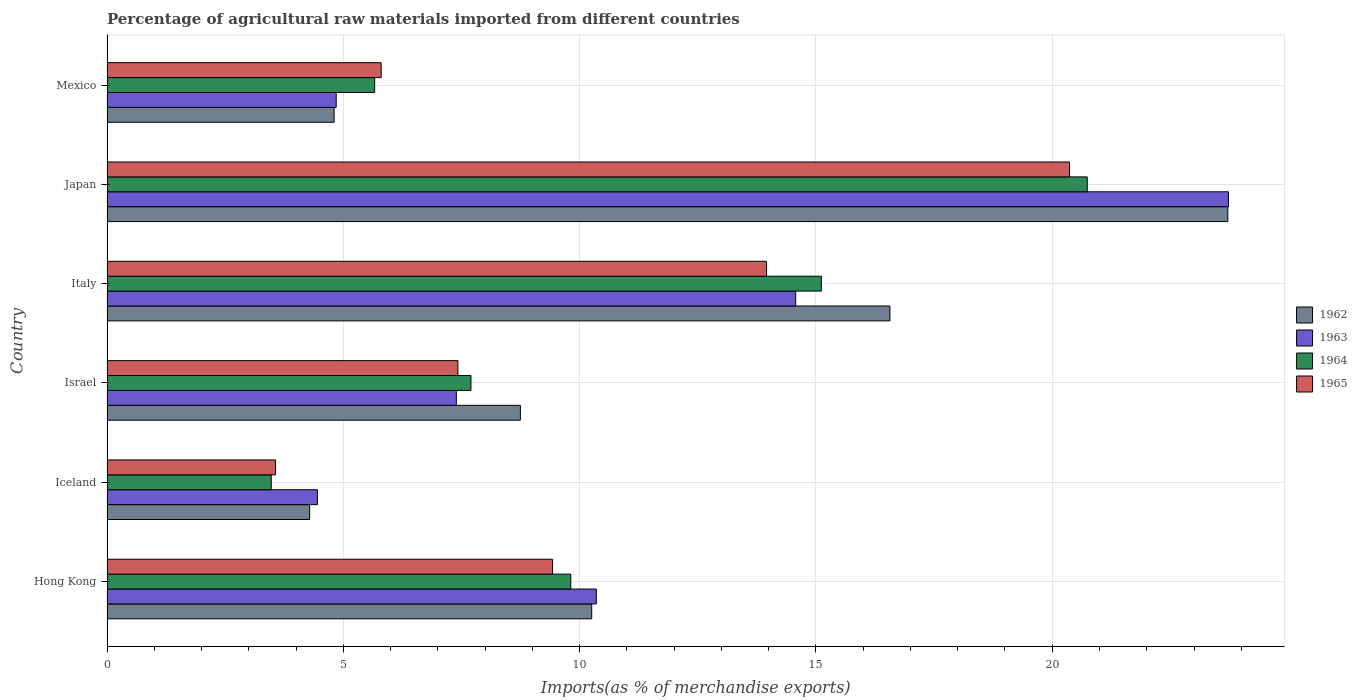How many different coloured bars are there?
Provide a succinct answer. 4. How many bars are there on the 3rd tick from the top?
Your response must be concise. 4. How many bars are there on the 1st tick from the bottom?
Your response must be concise. 4. What is the label of the 5th group of bars from the top?
Offer a very short reply. Iceland. In how many cases, is the number of bars for a given country not equal to the number of legend labels?
Offer a very short reply. 0. What is the percentage of imports to different countries in 1965 in Italy?
Provide a succinct answer. 13.95. Across all countries, what is the maximum percentage of imports to different countries in 1962?
Your answer should be very brief. 23.71. Across all countries, what is the minimum percentage of imports to different countries in 1963?
Your answer should be very brief. 4.45. What is the total percentage of imports to different countries in 1964 in the graph?
Keep it short and to the point. 62.51. What is the difference between the percentage of imports to different countries in 1965 in Iceland and that in Italy?
Offer a terse response. -10.39. What is the difference between the percentage of imports to different countries in 1963 in Japan and the percentage of imports to different countries in 1965 in Iceland?
Your answer should be very brief. 20.16. What is the average percentage of imports to different countries in 1965 per country?
Your response must be concise. 10.09. What is the difference between the percentage of imports to different countries in 1965 and percentage of imports to different countries in 1963 in Mexico?
Offer a very short reply. 0.95. In how many countries, is the percentage of imports to different countries in 1963 greater than 4 %?
Make the answer very short. 6. What is the ratio of the percentage of imports to different countries in 1963 in Hong Kong to that in Italy?
Offer a terse response. 0.71. Is the percentage of imports to different countries in 1962 in Italy less than that in Japan?
Provide a succinct answer. Yes. Is the difference between the percentage of imports to different countries in 1965 in Iceland and Japan greater than the difference between the percentage of imports to different countries in 1963 in Iceland and Japan?
Ensure brevity in your answer.  Yes. What is the difference between the highest and the second highest percentage of imports to different countries in 1964?
Provide a short and direct response. 5.63. What is the difference between the highest and the lowest percentage of imports to different countries in 1965?
Give a very brief answer. 16.8. In how many countries, is the percentage of imports to different countries in 1965 greater than the average percentage of imports to different countries in 1965 taken over all countries?
Your answer should be compact. 2. What does the 1st bar from the top in Japan represents?
Your response must be concise. 1965. What does the 3rd bar from the bottom in Japan represents?
Keep it short and to the point. 1964. Is it the case that in every country, the sum of the percentage of imports to different countries in 1962 and percentage of imports to different countries in 1963 is greater than the percentage of imports to different countries in 1965?
Provide a succinct answer. Yes. Does the graph contain any zero values?
Ensure brevity in your answer.  No. Does the graph contain grids?
Your response must be concise. Yes. Where does the legend appear in the graph?
Offer a very short reply. Center right. How many legend labels are there?
Your answer should be compact. 4. What is the title of the graph?
Give a very brief answer. Percentage of agricultural raw materials imported from different countries. What is the label or title of the X-axis?
Your response must be concise. Imports(as % of merchandise exports). What is the label or title of the Y-axis?
Ensure brevity in your answer.  Country. What is the Imports(as % of merchandise exports) in 1962 in Hong Kong?
Provide a succinct answer. 10.26. What is the Imports(as % of merchandise exports) in 1963 in Hong Kong?
Your response must be concise. 10.35. What is the Imports(as % of merchandise exports) of 1964 in Hong Kong?
Keep it short and to the point. 9.81. What is the Imports(as % of merchandise exports) of 1965 in Hong Kong?
Make the answer very short. 9.43. What is the Imports(as % of merchandise exports) of 1962 in Iceland?
Your response must be concise. 4.29. What is the Imports(as % of merchandise exports) in 1963 in Iceland?
Provide a short and direct response. 4.45. What is the Imports(as % of merchandise exports) in 1964 in Iceland?
Offer a very short reply. 3.48. What is the Imports(as % of merchandise exports) of 1965 in Iceland?
Your answer should be compact. 3.57. What is the Imports(as % of merchandise exports) in 1962 in Israel?
Your answer should be compact. 8.75. What is the Imports(as % of merchandise exports) in 1963 in Israel?
Offer a very short reply. 7.39. What is the Imports(as % of merchandise exports) in 1964 in Israel?
Give a very brief answer. 7.7. What is the Imports(as % of merchandise exports) in 1965 in Israel?
Your answer should be compact. 7.42. What is the Imports(as % of merchandise exports) in 1962 in Italy?
Offer a very short reply. 16.57. What is the Imports(as % of merchandise exports) in 1963 in Italy?
Make the answer very short. 14.57. What is the Imports(as % of merchandise exports) of 1964 in Italy?
Provide a succinct answer. 15.12. What is the Imports(as % of merchandise exports) of 1965 in Italy?
Ensure brevity in your answer.  13.95. What is the Imports(as % of merchandise exports) in 1962 in Japan?
Make the answer very short. 23.71. What is the Imports(as % of merchandise exports) in 1963 in Japan?
Your answer should be compact. 23.73. What is the Imports(as % of merchandise exports) of 1964 in Japan?
Your response must be concise. 20.74. What is the Imports(as % of merchandise exports) in 1965 in Japan?
Keep it short and to the point. 20.37. What is the Imports(as % of merchandise exports) of 1962 in Mexico?
Make the answer very short. 4.81. What is the Imports(as % of merchandise exports) in 1963 in Mexico?
Make the answer very short. 4.85. What is the Imports(as % of merchandise exports) in 1964 in Mexico?
Offer a terse response. 5.66. What is the Imports(as % of merchandise exports) in 1965 in Mexico?
Offer a terse response. 5.8. Across all countries, what is the maximum Imports(as % of merchandise exports) in 1962?
Make the answer very short. 23.71. Across all countries, what is the maximum Imports(as % of merchandise exports) in 1963?
Make the answer very short. 23.73. Across all countries, what is the maximum Imports(as % of merchandise exports) of 1964?
Offer a terse response. 20.74. Across all countries, what is the maximum Imports(as % of merchandise exports) of 1965?
Offer a terse response. 20.37. Across all countries, what is the minimum Imports(as % of merchandise exports) in 1962?
Your response must be concise. 4.29. Across all countries, what is the minimum Imports(as % of merchandise exports) in 1963?
Your answer should be very brief. 4.45. Across all countries, what is the minimum Imports(as % of merchandise exports) in 1964?
Offer a terse response. 3.48. Across all countries, what is the minimum Imports(as % of merchandise exports) in 1965?
Your answer should be compact. 3.57. What is the total Imports(as % of merchandise exports) of 1962 in the graph?
Ensure brevity in your answer.  68.38. What is the total Imports(as % of merchandise exports) of 1963 in the graph?
Give a very brief answer. 65.35. What is the total Imports(as % of merchandise exports) in 1964 in the graph?
Provide a short and direct response. 62.51. What is the total Imports(as % of merchandise exports) in 1965 in the graph?
Your answer should be compact. 60.54. What is the difference between the Imports(as % of merchandise exports) of 1962 in Hong Kong and that in Iceland?
Make the answer very short. 5.97. What is the difference between the Imports(as % of merchandise exports) of 1963 in Hong Kong and that in Iceland?
Your answer should be very brief. 5.9. What is the difference between the Imports(as % of merchandise exports) of 1964 in Hong Kong and that in Iceland?
Ensure brevity in your answer.  6.34. What is the difference between the Imports(as % of merchandise exports) in 1965 in Hong Kong and that in Iceland?
Offer a very short reply. 5.86. What is the difference between the Imports(as % of merchandise exports) in 1962 in Hong Kong and that in Israel?
Offer a very short reply. 1.51. What is the difference between the Imports(as % of merchandise exports) of 1963 in Hong Kong and that in Israel?
Give a very brief answer. 2.96. What is the difference between the Imports(as % of merchandise exports) in 1964 in Hong Kong and that in Israel?
Offer a terse response. 2.11. What is the difference between the Imports(as % of merchandise exports) of 1965 in Hong Kong and that in Israel?
Ensure brevity in your answer.  2. What is the difference between the Imports(as % of merchandise exports) in 1962 in Hong Kong and that in Italy?
Keep it short and to the point. -6.31. What is the difference between the Imports(as % of merchandise exports) in 1963 in Hong Kong and that in Italy?
Keep it short and to the point. -4.22. What is the difference between the Imports(as % of merchandise exports) of 1964 in Hong Kong and that in Italy?
Keep it short and to the point. -5.3. What is the difference between the Imports(as % of merchandise exports) of 1965 in Hong Kong and that in Italy?
Your answer should be very brief. -4.53. What is the difference between the Imports(as % of merchandise exports) of 1962 in Hong Kong and that in Japan?
Offer a terse response. -13.46. What is the difference between the Imports(as % of merchandise exports) of 1963 in Hong Kong and that in Japan?
Provide a succinct answer. -13.38. What is the difference between the Imports(as % of merchandise exports) in 1964 in Hong Kong and that in Japan?
Your response must be concise. -10.93. What is the difference between the Imports(as % of merchandise exports) of 1965 in Hong Kong and that in Japan?
Your answer should be very brief. -10.94. What is the difference between the Imports(as % of merchandise exports) of 1962 in Hong Kong and that in Mexico?
Make the answer very short. 5.45. What is the difference between the Imports(as % of merchandise exports) of 1963 in Hong Kong and that in Mexico?
Your answer should be very brief. 5.5. What is the difference between the Imports(as % of merchandise exports) in 1964 in Hong Kong and that in Mexico?
Make the answer very short. 4.15. What is the difference between the Imports(as % of merchandise exports) of 1965 in Hong Kong and that in Mexico?
Make the answer very short. 3.63. What is the difference between the Imports(as % of merchandise exports) of 1962 in Iceland and that in Israel?
Give a very brief answer. -4.46. What is the difference between the Imports(as % of merchandise exports) of 1963 in Iceland and that in Israel?
Offer a terse response. -2.94. What is the difference between the Imports(as % of merchandise exports) in 1964 in Iceland and that in Israel?
Your response must be concise. -4.23. What is the difference between the Imports(as % of merchandise exports) in 1965 in Iceland and that in Israel?
Keep it short and to the point. -3.86. What is the difference between the Imports(as % of merchandise exports) in 1962 in Iceland and that in Italy?
Ensure brevity in your answer.  -12.28. What is the difference between the Imports(as % of merchandise exports) of 1963 in Iceland and that in Italy?
Ensure brevity in your answer.  -10.12. What is the difference between the Imports(as % of merchandise exports) in 1964 in Iceland and that in Italy?
Keep it short and to the point. -11.64. What is the difference between the Imports(as % of merchandise exports) in 1965 in Iceland and that in Italy?
Your answer should be compact. -10.39. What is the difference between the Imports(as % of merchandise exports) in 1962 in Iceland and that in Japan?
Provide a succinct answer. -19.43. What is the difference between the Imports(as % of merchandise exports) in 1963 in Iceland and that in Japan?
Your answer should be compact. -19.28. What is the difference between the Imports(as % of merchandise exports) in 1964 in Iceland and that in Japan?
Offer a very short reply. -17.27. What is the difference between the Imports(as % of merchandise exports) of 1965 in Iceland and that in Japan?
Make the answer very short. -16.8. What is the difference between the Imports(as % of merchandise exports) of 1962 in Iceland and that in Mexico?
Provide a short and direct response. -0.52. What is the difference between the Imports(as % of merchandise exports) in 1963 in Iceland and that in Mexico?
Give a very brief answer. -0.4. What is the difference between the Imports(as % of merchandise exports) of 1964 in Iceland and that in Mexico?
Your response must be concise. -2.19. What is the difference between the Imports(as % of merchandise exports) in 1965 in Iceland and that in Mexico?
Make the answer very short. -2.23. What is the difference between the Imports(as % of merchandise exports) in 1962 in Israel and that in Italy?
Offer a terse response. -7.82. What is the difference between the Imports(as % of merchandise exports) in 1963 in Israel and that in Italy?
Your answer should be compact. -7.18. What is the difference between the Imports(as % of merchandise exports) in 1964 in Israel and that in Italy?
Your answer should be compact. -7.41. What is the difference between the Imports(as % of merchandise exports) in 1965 in Israel and that in Italy?
Offer a very short reply. -6.53. What is the difference between the Imports(as % of merchandise exports) in 1962 in Israel and that in Japan?
Provide a short and direct response. -14.97. What is the difference between the Imports(as % of merchandise exports) of 1963 in Israel and that in Japan?
Your answer should be very brief. -16.34. What is the difference between the Imports(as % of merchandise exports) of 1964 in Israel and that in Japan?
Make the answer very short. -13.04. What is the difference between the Imports(as % of merchandise exports) of 1965 in Israel and that in Japan?
Your answer should be very brief. -12.94. What is the difference between the Imports(as % of merchandise exports) of 1962 in Israel and that in Mexico?
Offer a terse response. 3.94. What is the difference between the Imports(as % of merchandise exports) in 1963 in Israel and that in Mexico?
Give a very brief answer. 2.54. What is the difference between the Imports(as % of merchandise exports) in 1964 in Israel and that in Mexico?
Your answer should be very brief. 2.04. What is the difference between the Imports(as % of merchandise exports) in 1965 in Israel and that in Mexico?
Your answer should be very brief. 1.62. What is the difference between the Imports(as % of merchandise exports) of 1962 in Italy and that in Japan?
Keep it short and to the point. -7.15. What is the difference between the Imports(as % of merchandise exports) in 1963 in Italy and that in Japan?
Give a very brief answer. -9.16. What is the difference between the Imports(as % of merchandise exports) of 1964 in Italy and that in Japan?
Offer a terse response. -5.63. What is the difference between the Imports(as % of merchandise exports) of 1965 in Italy and that in Japan?
Offer a terse response. -6.41. What is the difference between the Imports(as % of merchandise exports) in 1962 in Italy and that in Mexico?
Offer a very short reply. 11.76. What is the difference between the Imports(as % of merchandise exports) in 1963 in Italy and that in Mexico?
Your response must be concise. 9.72. What is the difference between the Imports(as % of merchandise exports) of 1964 in Italy and that in Mexico?
Your answer should be compact. 9.45. What is the difference between the Imports(as % of merchandise exports) in 1965 in Italy and that in Mexico?
Provide a succinct answer. 8.15. What is the difference between the Imports(as % of merchandise exports) of 1962 in Japan and that in Mexico?
Keep it short and to the point. 18.91. What is the difference between the Imports(as % of merchandise exports) in 1963 in Japan and that in Mexico?
Your response must be concise. 18.88. What is the difference between the Imports(as % of merchandise exports) of 1964 in Japan and that in Mexico?
Keep it short and to the point. 15.08. What is the difference between the Imports(as % of merchandise exports) of 1965 in Japan and that in Mexico?
Your response must be concise. 14.56. What is the difference between the Imports(as % of merchandise exports) of 1962 in Hong Kong and the Imports(as % of merchandise exports) of 1963 in Iceland?
Your response must be concise. 5.8. What is the difference between the Imports(as % of merchandise exports) in 1962 in Hong Kong and the Imports(as % of merchandise exports) in 1964 in Iceland?
Your response must be concise. 6.78. What is the difference between the Imports(as % of merchandise exports) in 1962 in Hong Kong and the Imports(as % of merchandise exports) in 1965 in Iceland?
Ensure brevity in your answer.  6.69. What is the difference between the Imports(as % of merchandise exports) of 1963 in Hong Kong and the Imports(as % of merchandise exports) of 1964 in Iceland?
Offer a terse response. 6.88. What is the difference between the Imports(as % of merchandise exports) of 1963 in Hong Kong and the Imports(as % of merchandise exports) of 1965 in Iceland?
Make the answer very short. 6.79. What is the difference between the Imports(as % of merchandise exports) in 1964 in Hong Kong and the Imports(as % of merchandise exports) in 1965 in Iceland?
Make the answer very short. 6.25. What is the difference between the Imports(as % of merchandise exports) of 1962 in Hong Kong and the Imports(as % of merchandise exports) of 1963 in Israel?
Make the answer very short. 2.86. What is the difference between the Imports(as % of merchandise exports) of 1962 in Hong Kong and the Imports(as % of merchandise exports) of 1964 in Israel?
Your answer should be very brief. 2.55. What is the difference between the Imports(as % of merchandise exports) in 1962 in Hong Kong and the Imports(as % of merchandise exports) in 1965 in Israel?
Your answer should be very brief. 2.83. What is the difference between the Imports(as % of merchandise exports) in 1963 in Hong Kong and the Imports(as % of merchandise exports) in 1964 in Israel?
Give a very brief answer. 2.65. What is the difference between the Imports(as % of merchandise exports) of 1963 in Hong Kong and the Imports(as % of merchandise exports) of 1965 in Israel?
Make the answer very short. 2.93. What is the difference between the Imports(as % of merchandise exports) of 1964 in Hong Kong and the Imports(as % of merchandise exports) of 1965 in Israel?
Your response must be concise. 2.39. What is the difference between the Imports(as % of merchandise exports) in 1962 in Hong Kong and the Imports(as % of merchandise exports) in 1963 in Italy?
Give a very brief answer. -4.32. What is the difference between the Imports(as % of merchandise exports) in 1962 in Hong Kong and the Imports(as % of merchandise exports) in 1964 in Italy?
Your response must be concise. -4.86. What is the difference between the Imports(as % of merchandise exports) of 1962 in Hong Kong and the Imports(as % of merchandise exports) of 1965 in Italy?
Offer a terse response. -3.7. What is the difference between the Imports(as % of merchandise exports) in 1963 in Hong Kong and the Imports(as % of merchandise exports) in 1964 in Italy?
Provide a succinct answer. -4.76. What is the difference between the Imports(as % of merchandise exports) in 1963 in Hong Kong and the Imports(as % of merchandise exports) in 1965 in Italy?
Provide a succinct answer. -3.6. What is the difference between the Imports(as % of merchandise exports) in 1964 in Hong Kong and the Imports(as % of merchandise exports) in 1965 in Italy?
Your response must be concise. -4.14. What is the difference between the Imports(as % of merchandise exports) of 1962 in Hong Kong and the Imports(as % of merchandise exports) of 1963 in Japan?
Ensure brevity in your answer.  -13.47. What is the difference between the Imports(as % of merchandise exports) of 1962 in Hong Kong and the Imports(as % of merchandise exports) of 1964 in Japan?
Your answer should be compact. -10.49. What is the difference between the Imports(as % of merchandise exports) of 1962 in Hong Kong and the Imports(as % of merchandise exports) of 1965 in Japan?
Offer a terse response. -10.11. What is the difference between the Imports(as % of merchandise exports) of 1963 in Hong Kong and the Imports(as % of merchandise exports) of 1964 in Japan?
Offer a terse response. -10.39. What is the difference between the Imports(as % of merchandise exports) in 1963 in Hong Kong and the Imports(as % of merchandise exports) in 1965 in Japan?
Offer a terse response. -10.01. What is the difference between the Imports(as % of merchandise exports) of 1964 in Hong Kong and the Imports(as % of merchandise exports) of 1965 in Japan?
Provide a short and direct response. -10.55. What is the difference between the Imports(as % of merchandise exports) of 1962 in Hong Kong and the Imports(as % of merchandise exports) of 1963 in Mexico?
Offer a very short reply. 5.41. What is the difference between the Imports(as % of merchandise exports) in 1962 in Hong Kong and the Imports(as % of merchandise exports) in 1964 in Mexico?
Provide a short and direct response. 4.59. What is the difference between the Imports(as % of merchandise exports) in 1962 in Hong Kong and the Imports(as % of merchandise exports) in 1965 in Mexico?
Ensure brevity in your answer.  4.45. What is the difference between the Imports(as % of merchandise exports) in 1963 in Hong Kong and the Imports(as % of merchandise exports) in 1964 in Mexico?
Your answer should be compact. 4.69. What is the difference between the Imports(as % of merchandise exports) in 1963 in Hong Kong and the Imports(as % of merchandise exports) in 1965 in Mexico?
Offer a terse response. 4.55. What is the difference between the Imports(as % of merchandise exports) in 1964 in Hong Kong and the Imports(as % of merchandise exports) in 1965 in Mexico?
Offer a terse response. 4.01. What is the difference between the Imports(as % of merchandise exports) in 1962 in Iceland and the Imports(as % of merchandise exports) in 1963 in Israel?
Make the answer very short. -3.1. What is the difference between the Imports(as % of merchandise exports) in 1962 in Iceland and the Imports(as % of merchandise exports) in 1964 in Israel?
Give a very brief answer. -3.41. What is the difference between the Imports(as % of merchandise exports) of 1962 in Iceland and the Imports(as % of merchandise exports) of 1965 in Israel?
Keep it short and to the point. -3.14. What is the difference between the Imports(as % of merchandise exports) of 1963 in Iceland and the Imports(as % of merchandise exports) of 1964 in Israel?
Ensure brevity in your answer.  -3.25. What is the difference between the Imports(as % of merchandise exports) in 1963 in Iceland and the Imports(as % of merchandise exports) in 1965 in Israel?
Your answer should be very brief. -2.97. What is the difference between the Imports(as % of merchandise exports) in 1964 in Iceland and the Imports(as % of merchandise exports) in 1965 in Israel?
Offer a very short reply. -3.95. What is the difference between the Imports(as % of merchandise exports) of 1962 in Iceland and the Imports(as % of merchandise exports) of 1963 in Italy?
Ensure brevity in your answer.  -10.28. What is the difference between the Imports(as % of merchandise exports) of 1962 in Iceland and the Imports(as % of merchandise exports) of 1964 in Italy?
Keep it short and to the point. -10.83. What is the difference between the Imports(as % of merchandise exports) in 1962 in Iceland and the Imports(as % of merchandise exports) in 1965 in Italy?
Give a very brief answer. -9.67. What is the difference between the Imports(as % of merchandise exports) in 1963 in Iceland and the Imports(as % of merchandise exports) in 1964 in Italy?
Offer a very short reply. -10.66. What is the difference between the Imports(as % of merchandise exports) in 1963 in Iceland and the Imports(as % of merchandise exports) in 1965 in Italy?
Your answer should be compact. -9.5. What is the difference between the Imports(as % of merchandise exports) of 1964 in Iceland and the Imports(as % of merchandise exports) of 1965 in Italy?
Your answer should be compact. -10.48. What is the difference between the Imports(as % of merchandise exports) in 1962 in Iceland and the Imports(as % of merchandise exports) in 1963 in Japan?
Provide a succinct answer. -19.44. What is the difference between the Imports(as % of merchandise exports) in 1962 in Iceland and the Imports(as % of merchandise exports) in 1964 in Japan?
Make the answer very short. -16.45. What is the difference between the Imports(as % of merchandise exports) of 1962 in Iceland and the Imports(as % of merchandise exports) of 1965 in Japan?
Offer a very short reply. -16.08. What is the difference between the Imports(as % of merchandise exports) in 1963 in Iceland and the Imports(as % of merchandise exports) in 1964 in Japan?
Ensure brevity in your answer.  -16.29. What is the difference between the Imports(as % of merchandise exports) in 1963 in Iceland and the Imports(as % of merchandise exports) in 1965 in Japan?
Provide a succinct answer. -15.91. What is the difference between the Imports(as % of merchandise exports) of 1964 in Iceland and the Imports(as % of merchandise exports) of 1965 in Japan?
Provide a short and direct response. -16.89. What is the difference between the Imports(as % of merchandise exports) of 1962 in Iceland and the Imports(as % of merchandise exports) of 1963 in Mexico?
Give a very brief answer. -0.56. What is the difference between the Imports(as % of merchandise exports) of 1962 in Iceland and the Imports(as % of merchandise exports) of 1964 in Mexico?
Ensure brevity in your answer.  -1.38. What is the difference between the Imports(as % of merchandise exports) in 1962 in Iceland and the Imports(as % of merchandise exports) in 1965 in Mexico?
Your answer should be very brief. -1.51. What is the difference between the Imports(as % of merchandise exports) of 1963 in Iceland and the Imports(as % of merchandise exports) of 1964 in Mexico?
Keep it short and to the point. -1.21. What is the difference between the Imports(as % of merchandise exports) of 1963 in Iceland and the Imports(as % of merchandise exports) of 1965 in Mexico?
Ensure brevity in your answer.  -1.35. What is the difference between the Imports(as % of merchandise exports) in 1964 in Iceland and the Imports(as % of merchandise exports) in 1965 in Mexico?
Keep it short and to the point. -2.33. What is the difference between the Imports(as % of merchandise exports) in 1962 in Israel and the Imports(as % of merchandise exports) in 1963 in Italy?
Ensure brevity in your answer.  -5.83. What is the difference between the Imports(as % of merchandise exports) in 1962 in Israel and the Imports(as % of merchandise exports) in 1964 in Italy?
Offer a very short reply. -6.37. What is the difference between the Imports(as % of merchandise exports) of 1962 in Israel and the Imports(as % of merchandise exports) of 1965 in Italy?
Your answer should be very brief. -5.21. What is the difference between the Imports(as % of merchandise exports) in 1963 in Israel and the Imports(as % of merchandise exports) in 1964 in Italy?
Offer a very short reply. -7.72. What is the difference between the Imports(as % of merchandise exports) in 1963 in Israel and the Imports(as % of merchandise exports) in 1965 in Italy?
Make the answer very short. -6.56. What is the difference between the Imports(as % of merchandise exports) of 1964 in Israel and the Imports(as % of merchandise exports) of 1965 in Italy?
Your response must be concise. -6.25. What is the difference between the Imports(as % of merchandise exports) in 1962 in Israel and the Imports(as % of merchandise exports) in 1963 in Japan?
Your answer should be compact. -14.98. What is the difference between the Imports(as % of merchandise exports) of 1962 in Israel and the Imports(as % of merchandise exports) of 1964 in Japan?
Your answer should be compact. -11.99. What is the difference between the Imports(as % of merchandise exports) in 1962 in Israel and the Imports(as % of merchandise exports) in 1965 in Japan?
Your answer should be compact. -11.62. What is the difference between the Imports(as % of merchandise exports) in 1963 in Israel and the Imports(as % of merchandise exports) in 1964 in Japan?
Keep it short and to the point. -13.35. What is the difference between the Imports(as % of merchandise exports) in 1963 in Israel and the Imports(as % of merchandise exports) in 1965 in Japan?
Ensure brevity in your answer.  -12.97. What is the difference between the Imports(as % of merchandise exports) in 1964 in Israel and the Imports(as % of merchandise exports) in 1965 in Japan?
Offer a very short reply. -12.67. What is the difference between the Imports(as % of merchandise exports) of 1962 in Israel and the Imports(as % of merchandise exports) of 1963 in Mexico?
Your response must be concise. 3.9. What is the difference between the Imports(as % of merchandise exports) in 1962 in Israel and the Imports(as % of merchandise exports) in 1964 in Mexico?
Your answer should be very brief. 3.08. What is the difference between the Imports(as % of merchandise exports) in 1962 in Israel and the Imports(as % of merchandise exports) in 1965 in Mexico?
Provide a short and direct response. 2.95. What is the difference between the Imports(as % of merchandise exports) of 1963 in Israel and the Imports(as % of merchandise exports) of 1964 in Mexico?
Your response must be concise. 1.73. What is the difference between the Imports(as % of merchandise exports) of 1963 in Israel and the Imports(as % of merchandise exports) of 1965 in Mexico?
Provide a short and direct response. 1.59. What is the difference between the Imports(as % of merchandise exports) of 1964 in Israel and the Imports(as % of merchandise exports) of 1965 in Mexico?
Keep it short and to the point. 1.9. What is the difference between the Imports(as % of merchandise exports) in 1962 in Italy and the Imports(as % of merchandise exports) in 1963 in Japan?
Your response must be concise. -7.16. What is the difference between the Imports(as % of merchandise exports) in 1962 in Italy and the Imports(as % of merchandise exports) in 1964 in Japan?
Offer a very short reply. -4.18. What is the difference between the Imports(as % of merchandise exports) of 1962 in Italy and the Imports(as % of merchandise exports) of 1965 in Japan?
Offer a terse response. -3.8. What is the difference between the Imports(as % of merchandise exports) of 1963 in Italy and the Imports(as % of merchandise exports) of 1964 in Japan?
Provide a succinct answer. -6.17. What is the difference between the Imports(as % of merchandise exports) of 1963 in Italy and the Imports(as % of merchandise exports) of 1965 in Japan?
Offer a very short reply. -5.79. What is the difference between the Imports(as % of merchandise exports) in 1964 in Italy and the Imports(as % of merchandise exports) in 1965 in Japan?
Your answer should be compact. -5.25. What is the difference between the Imports(as % of merchandise exports) of 1962 in Italy and the Imports(as % of merchandise exports) of 1963 in Mexico?
Offer a terse response. 11.72. What is the difference between the Imports(as % of merchandise exports) in 1962 in Italy and the Imports(as % of merchandise exports) in 1964 in Mexico?
Your answer should be very brief. 10.9. What is the difference between the Imports(as % of merchandise exports) of 1962 in Italy and the Imports(as % of merchandise exports) of 1965 in Mexico?
Your answer should be very brief. 10.76. What is the difference between the Imports(as % of merchandise exports) of 1963 in Italy and the Imports(as % of merchandise exports) of 1964 in Mexico?
Make the answer very short. 8.91. What is the difference between the Imports(as % of merchandise exports) in 1963 in Italy and the Imports(as % of merchandise exports) in 1965 in Mexico?
Your answer should be very brief. 8.77. What is the difference between the Imports(as % of merchandise exports) in 1964 in Italy and the Imports(as % of merchandise exports) in 1965 in Mexico?
Give a very brief answer. 9.31. What is the difference between the Imports(as % of merchandise exports) of 1962 in Japan and the Imports(as % of merchandise exports) of 1963 in Mexico?
Your answer should be very brief. 18.87. What is the difference between the Imports(as % of merchandise exports) in 1962 in Japan and the Imports(as % of merchandise exports) in 1964 in Mexico?
Offer a terse response. 18.05. What is the difference between the Imports(as % of merchandise exports) in 1962 in Japan and the Imports(as % of merchandise exports) in 1965 in Mexico?
Your response must be concise. 17.91. What is the difference between the Imports(as % of merchandise exports) of 1963 in Japan and the Imports(as % of merchandise exports) of 1964 in Mexico?
Keep it short and to the point. 18.07. What is the difference between the Imports(as % of merchandise exports) in 1963 in Japan and the Imports(as % of merchandise exports) in 1965 in Mexico?
Offer a terse response. 17.93. What is the difference between the Imports(as % of merchandise exports) in 1964 in Japan and the Imports(as % of merchandise exports) in 1965 in Mexico?
Your answer should be compact. 14.94. What is the average Imports(as % of merchandise exports) in 1962 per country?
Your response must be concise. 11.4. What is the average Imports(as % of merchandise exports) in 1963 per country?
Offer a very short reply. 10.89. What is the average Imports(as % of merchandise exports) of 1964 per country?
Your answer should be very brief. 10.42. What is the average Imports(as % of merchandise exports) of 1965 per country?
Your response must be concise. 10.09. What is the difference between the Imports(as % of merchandise exports) in 1962 and Imports(as % of merchandise exports) in 1963 in Hong Kong?
Provide a succinct answer. -0.1. What is the difference between the Imports(as % of merchandise exports) in 1962 and Imports(as % of merchandise exports) in 1964 in Hong Kong?
Give a very brief answer. 0.44. What is the difference between the Imports(as % of merchandise exports) in 1962 and Imports(as % of merchandise exports) in 1965 in Hong Kong?
Give a very brief answer. 0.83. What is the difference between the Imports(as % of merchandise exports) in 1963 and Imports(as % of merchandise exports) in 1964 in Hong Kong?
Your response must be concise. 0.54. What is the difference between the Imports(as % of merchandise exports) in 1963 and Imports(as % of merchandise exports) in 1965 in Hong Kong?
Make the answer very short. 0.93. What is the difference between the Imports(as % of merchandise exports) of 1964 and Imports(as % of merchandise exports) of 1965 in Hong Kong?
Offer a terse response. 0.39. What is the difference between the Imports(as % of merchandise exports) in 1962 and Imports(as % of merchandise exports) in 1963 in Iceland?
Your answer should be very brief. -0.16. What is the difference between the Imports(as % of merchandise exports) of 1962 and Imports(as % of merchandise exports) of 1964 in Iceland?
Your answer should be very brief. 0.81. What is the difference between the Imports(as % of merchandise exports) in 1962 and Imports(as % of merchandise exports) in 1965 in Iceland?
Keep it short and to the point. 0.72. What is the difference between the Imports(as % of merchandise exports) of 1963 and Imports(as % of merchandise exports) of 1964 in Iceland?
Provide a succinct answer. 0.98. What is the difference between the Imports(as % of merchandise exports) of 1963 and Imports(as % of merchandise exports) of 1965 in Iceland?
Your answer should be very brief. 0.89. What is the difference between the Imports(as % of merchandise exports) of 1964 and Imports(as % of merchandise exports) of 1965 in Iceland?
Offer a very short reply. -0.09. What is the difference between the Imports(as % of merchandise exports) in 1962 and Imports(as % of merchandise exports) in 1963 in Israel?
Ensure brevity in your answer.  1.36. What is the difference between the Imports(as % of merchandise exports) in 1962 and Imports(as % of merchandise exports) in 1964 in Israel?
Provide a short and direct response. 1.05. What is the difference between the Imports(as % of merchandise exports) of 1962 and Imports(as % of merchandise exports) of 1965 in Israel?
Your response must be concise. 1.32. What is the difference between the Imports(as % of merchandise exports) of 1963 and Imports(as % of merchandise exports) of 1964 in Israel?
Your answer should be very brief. -0.31. What is the difference between the Imports(as % of merchandise exports) in 1963 and Imports(as % of merchandise exports) in 1965 in Israel?
Make the answer very short. -0.03. What is the difference between the Imports(as % of merchandise exports) in 1964 and Imports(as % of merchandise exports) in 1965 in Israel?
Offer a very short reply. 0.28. What is the difference between the Imports(as % of merchandise exports) in 1962 and Imports(as % of merchandise exports) in 1963 in Italy?
Ensure brevity in your answer.  1.99. What is the difference between the Imports(as % of merchandise exports) of 1962 and Imports(as % of merchandise exports) of 1964 in Italy?
Provide a succinct answer. 1.45. What is the difference between the Imports(as % of merchandise exports) in 1962 and Imports(as % of merchandise exports) in 1965 in Italy?
Keep it short and to the point. 2.61. What is the difference between the Imports(as % of merchandise exports) in 1963 and Imports(as % of merchandise exports) in 1964 in Italy?
Provide a short and direct response. -0.54. What is the difference between the Imports(as % of merchandise exports) in 1963 and Imports(as % of merchandise exports) in 1965 in Italy?
Keep it short and to the point. 0.62. What is the difference between the Imports(as % of merchandise exports) in 1964 and Imports(as % of merchandise exports) in 1965 in Italy?
Provide a short and direct response. 1.16. What is the difference between the Imports(as % of merchandise exports) of 1962 and Imports(as % of merchandise exports) of 1963 in Japan?
Your answer should be very brief. -0.01. What is the difference between the Imports(as % of merchandise exports) in 1962 and Imports(as % of merchandise exports) in 1964 in Japan?
Give a very brief answer. 2.97. What is the difference between the Imports(as % of merchandise exports) of 1962 and Imports(as % of merchandise exports) of 1965 in Japan?
Your answer should be compact. 3.35. What is the difference between the Imports(as % of merchandise exports) in 1963 and Imports(as % of merchandise exports) in 1964 in Japan?
Provide a succinct answer. 2.99. What is the difference between the Imports(as % of merchandise exports) in 1963 and Imports(as % of merchandise exports) in 1965 in Japan?
Make the answer very short. 3.36. What is the difference between the Imports(as % of merchandise exports) in 1964 and Imports(as % of merchandise exports) in 1965 in Japan?
Your response must be concise. 0.38. What is the difference between the Imports(as % of merchandise exports) in 1962 and Imports(as % of merchandise exports) in 1963 in Mexico?
Offer a terse response. -0.04. What is the difference between the Imports(as % of merchandise exports) in 1962 and Imports(as % of merchandise exports) in 1964 in Mexico?
Your answer should be very brief. -0.86. What is the difference between the Imports(as % of merchandise exports) in 1962 and Imports(as % of merchandise exports) in 1965 in Mexico?
Provide a short and direct response. -1. What is the difference between the Imports(as % of merchandise exports) of 1963 and Imports(as % of merchandise exports) of 1964 in Mexico?
Your answer should be compact. -0.81. What is the difference between the Imports(as % of merchandise exports) in 1963 and Imports(as % of merchandise exports) in 1965 in Mexico?
Make the answer very short. -0.95. What is the difference between the Imports(as % of merchandise exports) of 1964 and Imports(as % of merchandise exports) of 1965 in Mexico?
Ensure brevity in your answer.  -0.14. What is the ratio of the Imports(as % of merchandise exports) of 1962 in Hong Kong to that in Iceland?
Provide a short and direct response. 2.39. What is the ratio of the Imports(as % of merchandise exports) of 1963 in Hong Kong to that in Iceland?
Offer a very short reply. 2.33. What is the ratio of the Imports(as % of merchandise exports) of 1964 in Hong Kong to that in Iceland?
Offer a very short reply. 2.82. What is the ratio of the Imports(as % of merchandise exports) of 1965 in Hong Kong to that in Iceland?
Offer a very short reply. 2.64. What is the ratio of the Imports(as % of merchandise exports) in 1962 in Hong Kong to that in Israel?
Your answer should be compact. 1.17. What is the ratio of the Imports(as % of merchandise exports) in 1963 in Hong Kong to that in Israel?
Make the answer very short. 1.4. What is the ratio of the Imports(as % of merchandise exports) in 1964 in Hong Kong to that in Israel?
Offer a very short reply. 1.27. What is the ratio of the Imports(as % of merchandise exports) of 1965 in Hong Kong to that in Israel?
Offer a very short reply. 1.27. What is the ratio of the Imports(as % of merchandise exports) of 1962 in Hong Kong to that in Italy?
Ensure brevity in your answer.  0.62. What is the ratio of the Imports(as % of merchandise exports) in 1963 in Hong Kong to that in Italy?
Offer a terse response. 0.71. What is the ratio of the Imports(as % of merchandise exports) in 1964 in Hong Kong to that in Italy?
Your response must be concise. 0.65. What is the ratio of the Imports(as % of merchandise exports) in 1965 in Hong Kong to that in Italy?
Your answer should be very brief. 0.68. What is the ratio of the Imports(as % of merchandise exports) in 1962 in Hong Kong to that in Japan?
Your answer should be compact. 0.43. What is the ratio of the Imports(as % of merchandise exports) in 1963 in Hong Kong to that in Japan?
Your answer should be compact. 0.44. What is the ratio of the Imports(as % of merchandise exports) in 1964 in Hong Kong to that in Japan?
Provide a short and direct response. 0.47. What is the ratio of the Imports(as % of merchandise exports) in 1965 in Hong Kong to that in Japan?
Make the answer very short. 0.46. What is the ratio of the Imports(as % of merchandise exports) in 1962 in Hong Kong to that in Mexico?
Your answer should be very brief. 2.13. What is the ratio of the Imports(as % of merchandise exports) in 1963 in Hong Kong to that in Mexico?
Provide a short and direct response. 2.13. What is the ratio of the Imports(as % of merchandise exports) of 1964 in Hong Kong to that in Mexico?
Offer a very short reply. 1.73. What is the ratio of the Imports(as % of merchandise exports) of 1965 in Hong Kong to that in Mexico?
Keep it short and to the point. 1.63. What is the ratio of the Imports(as % of merchandise exports) in 1962 in Iceland to that in Israel?
Offer a terse response. 0.49. What is the ratio of the Imports(as % of merchandise exports) of 1963 in Iceland to that in Israel?
Your response must be concise. 0.6. What is the ratio of the Imports(as % of merchandise exports) in 1964 in Iceland to that in Israel?
Ensure brevity in your answer.  0.45. What is the ratio of the Imports(as % of merchandise exports) of 1965 in Iceland to that in Israel?
Provide a succinct answer. 0.48. What is the ratio of the Imports(as % of merchandise exports) of 1962 in Iceland to that in Italy?
Offer a very short reply. 0.26. What is the ratio of the Imports(as % of merchandise exports) of 1963 in Iceland to that in Italy?
Keep it short and to the point. 0.31. What is the ratio of the Imports(as % of merchandise exports) in 1964 in Iceland to that in Italy?
Offer a terse response. 0.23. What is the ratio of the Imports(as % of merchandise exports) of 1965 in Iceland to that in Italy?
Your answer should be compact. 0.26. What is the ratio of the Imports(as % of merchandise exports) of 1962 in Iceland to that in Japan?
Offer a very short reply. 0.18. What is the ratio of the Imports(as % of merchandise exports) in 1963 in Iceland to that in Japan?
Provide a succinct answer. 0.19. What is the ratio of the Imports(as % of merchandise exports) in 1964 in Iceland to that in Japan?
Your response must be concise. 0.17. What is the ratio of the Imports(as % of merchandise exports) of 1965 in Iceland to that in Japan?
Offer a terse response. 0.18. What is the ratio of the Imports(as % of merchandise exports) of 1962 in Iceland to that in Mexico?
Make the answer very short. 0.89. What is the ratio of the Imports(as % of merchandise exports) in 1963 in Iceland to that in Mexico?
Offer a terse response. 0.92. What is the ratio of the Imports(as % of merchandise exports) in 1964 in Iceland to that in Mexico?
Your answer should be very brief. 0.61. What is the ratio of the Imports(as % of merchandise exports) of 1965 in Iceland to that in Mexico?
Provide a short and direct response. 0.61. What is the ratio of the Imports(as % of merchandise exports) of 1962 in Israel to that in Italy?
Provide a succinct answer. 0.53. What is the ratio of the Imports(as % of merchandise exports) in 1963 in Israel to that in Italy?
Ensure brevity in your answer.  0.51. What is the ratio of the Imports(as % of merchandise exports) in 1964 in Israel to that in Italy?
Make the answer very short. 0.51. What is the ratio of the Imports(as % of merchandise exports) of 1965 in Israel to that in Italy?
Make the answer very short. 0.53. What is the ratio of the Imports(as % of merchandise exports) of 1962 in Israel to that in Japan?
Provide a short and direct response. 0.37. What is the ratio of the Imports(as % of merchandise exports) of 1963 in Israel to that in Japan?
Your answer should be compact. 0.31. What is the ratio of the Imports(as % of merchandise exports) in 1964 in Israel to that in Japan?
Offer a terse response. 0.37. What is the ratio of the Imports(as % of merchandise exports) of 1965 in Israel to that in Japan?
Your response must be concise. 0.36. What is the ratio of the Imports(as % of merchandise exports) of 1962 in Israel to that in Mexico?
Keep it short and to the point. 1.82. What is the ratio of the Imports(as % of merchandise exports) of 1963 in Israel to that in Mexico?
Provide a succinct answer. 1.52. What is the ratio of the Imports(as % of merchandise exports) of 1964 in Israel to that in Mexico?
Your answer should be very brief. 1.36. What is the ratio of the Imports(as % of merchandise exports) of 1965 in Israel to that in Mexico?
Your response must be concise. 1.28. What is the ratio of the Imports(as % of merchandise exports) in 1962 in Italy to that in Japan?
Provide a succinct answer. 0.7. What is the ratio of the Imports(as % of merchandise exports) of 1963 in Italy to that in Japan?
Give a very brief answer. 0.61. What is the ratio of the Imports(as % of merchandise exports) of 1964 in Italy to that in Japan?
Your response must be concise. 0.73. What is the ratio of the Imports(as % of merchandise exports) in 1965 in Italy to that in Japan?
Your response must be concise. 0.69. What is the ratio of the Imports(as % of merchandise exports) of 1962 in Italy to that in Mexico?
Give a very brief answer. 3.45. What is the ratio of the Imports(as % of merchandise exports) in 1963 in Italy to that in Mexico?
Offer a terse response. 3. What is the ratio of the Imports(as % of merchandise exports) in 1964 in Italy to that in Mexico?
Your response must be concise. 2.67. What is the ratio of the Imports(as % of merchandise exports) in 1965 in Italy to that in Mexico?
Provide a short and direct response. 2.41. What is the ratio of the Imports(as % of merchandise exports) of 1962 in Japan to that in Mexico?
Your answer should be very brief. 4.93. What is the ratio of the Imports(as % of merchandise exports) of 1963 in Japan to that in Mexico?
Give a very brief answer. 4.89. What is the ratio of the Imports(as % of merchandise exports) of 1964 in Japan to that in Mexico?
Make the answer very short. 3.66. What is the ratio of the Imports(as % of merchandise exports) of 1965 in Japan to that in Mexico?
Provide a short and direct response. 3.51. What is the difference between the highest and the second highest Imports(as % of merchandise exports) of 1962?
Your response must be concise. 7.15. What is the difference between the highest and the second highest Imports(as % of merchandise exports) in 1963?
Keep it short and to the point. 9.16. What is the difference between the highest and the second highest Imports(as % of merchandise exports) of 1964?
Offer a very short reply. 5.63. What is the difference between the highest and the second highest Imports(as % of merchandise exports) in 1965?
Your answer should be compact. 6.41. What is the difference between the highest and the lowest Imports(as % of merchandise exports) of 1962?
Provide a succinct answer. 19.43. What is the difference between the highest and the lowest Imports(as % of merchandise exports) of 1963?
Provide a succinct answer. 19.28. What is the difference between the highest and the lowest Imports(as % of merchandise exports) of 1964?
Your response must be concise. 17.27. What is the difference between the highest and the lowest Imports(as % of merchandise exports) of 1965?
Ensure brevity in your answer.  16.8. 